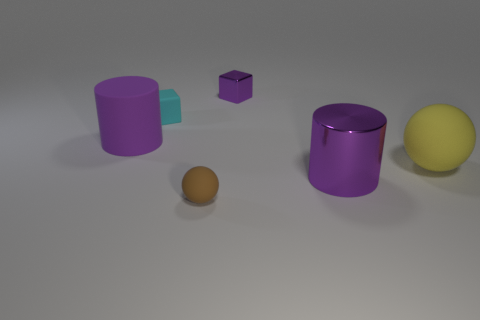Do the matte cylinder and the metal block have the same color?
Keep it short and to the point. Yes. There is a block that is the same color as the large metallic cylinder; what is its material?
Your response must be concise. Metal. What number of objects are small red things or big yellow objects?
Make the answer very short. 1. There is a thing that is both left of the yellow matte thing and on the right side of the purple shiny cube; how big is it?
Provide a short and direct response. Large. Are there fewer big cylinders in front of the purple rubber cylinder than small cubes?
Ensure brevity in your answer.  Yes. What shape is the purple thing that is the same material as the small brown ball?
Keep it short and to the point. Cylinder. There is a purple object in front of the large yellow rubber ball; is it the same shape as the purple thing that is behind the big matte cylinder?
Your answer should be very brief. No. Are there fewer metal objects in front of the big yellow rubber thing than large objects that are to the right of the matte block?
Ensure brevity in your answer.  Yes. What is the shape of the metallic thing that is the same color as the metal block?
Your response must be concise. Cylinder. How many other things have the same size as the brown rubber thing?
Give a very brief answer. 2. 